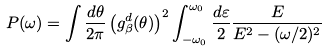<formula> <loc_0><loc_0><loc_500><loc_500>P ( \omega ) = \int \frac { d \theta } { 2 \pi } \left ( g ^ { d } _ { \beta } ( \theta ) \right ) ^ { 2 } \int ^ { \omega _ { 0 } } _ { - \omega _ { 0 } } \frac { d \varepsilon } { 2 } \frac { E } { E ^ { 2 } - ( \omega / 2 ) ^ { 2 } }</formula> 